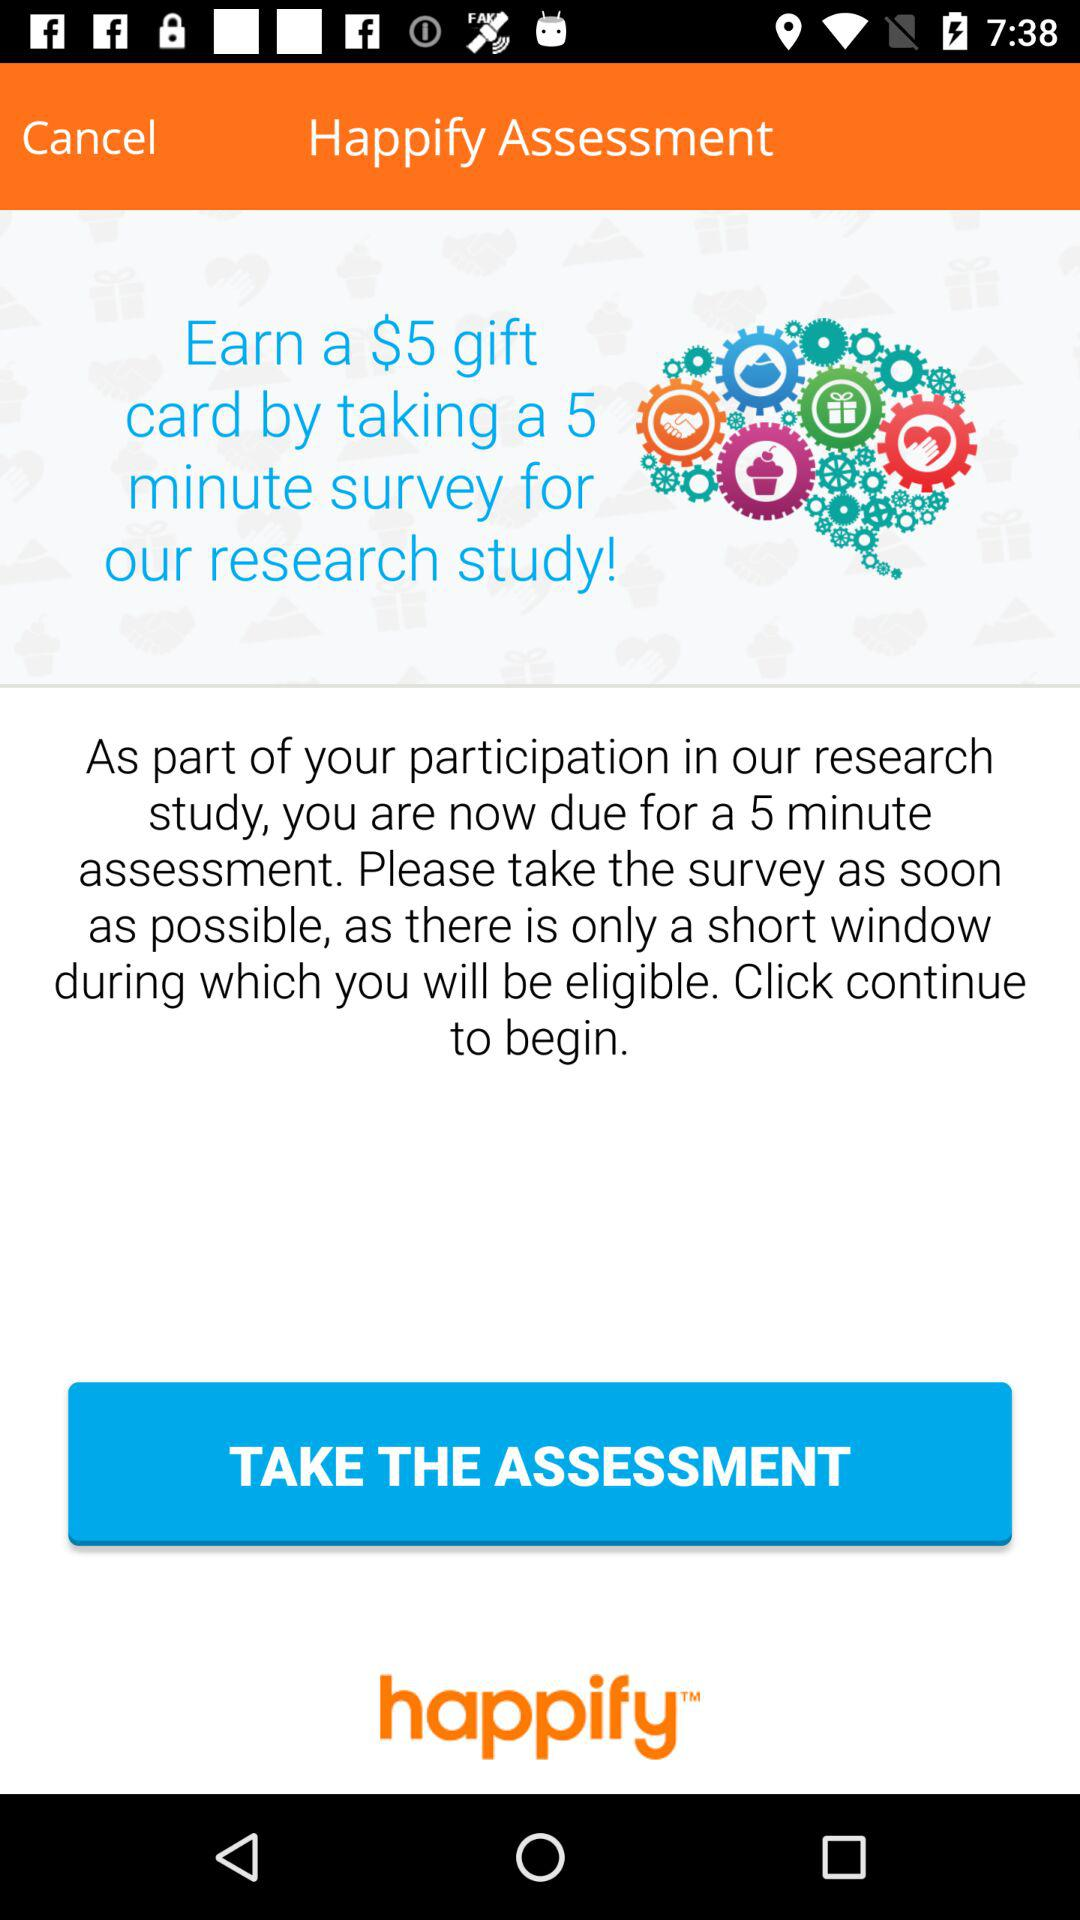How much can be earned by a 5-minute survey? You can earn a $5 gift card. 